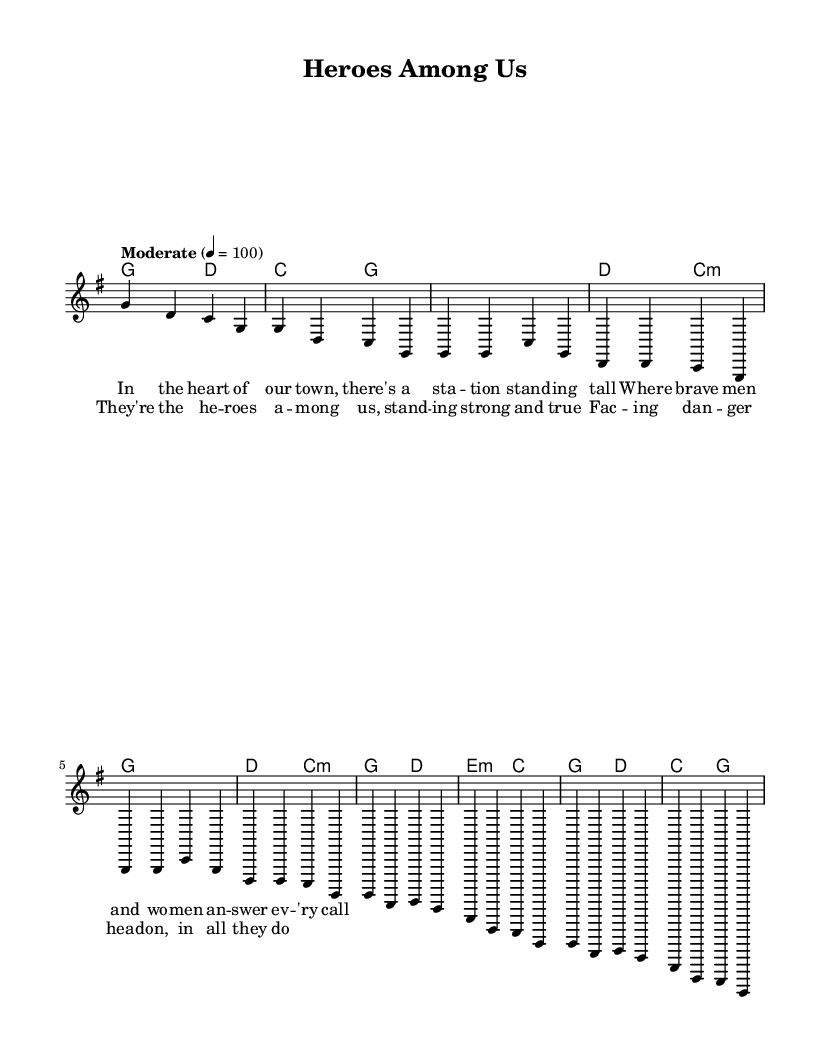What is the key signature of this music? The key signature is G major, which has one sharp (F#). The presence of sharp notes can be determined by examining the key signature placed on the staff at the beginning of the piece.
Answer: G major What is the time signature of the music? The time signature is 4/4, indicated by the fraction at the beginning of the piece, meaning there are four beats in each measure and the quarter note gets one beat.
Answer: 4/4 What is the tempo marking for this piece? The tempo marking is "Moderate" with a beat of 100 per minute. This information is typically indicated at the start of the score to guide the performance speed.
Answer: Moderate How many measures are in the chorus section? There are four measures in the chorus section. Counting from the beginning of the chorus lyrics and following the melody line, each phrase corresponds to a measure.
Answer: Four What phrases are repeated in the verse? The phrase "where brave men and women answer every call" is repeated in the verse structure, as indicated by the melodic and lyrical content. The repetition can be verified by examining the lyric layout and melody pattern.
Answer: Where brave men and women answer every call What chords are used in the chorus? The chords used in the chorus are G, D, E minor, and C. This is determined by analyzing the chord symbols written above the staff where the chorus lyrics are situated.
Answer: G, D, E minor, C What is the theme of the song based on the lyrics? The theme of the song is about celebrating first responders and hometown heroes, as indicated by phrases like "heroes among us" and the description of bravery in the lyrics. This thematic focus is reflected in the message of the lyrics.
Answer: Celebration of first responders 